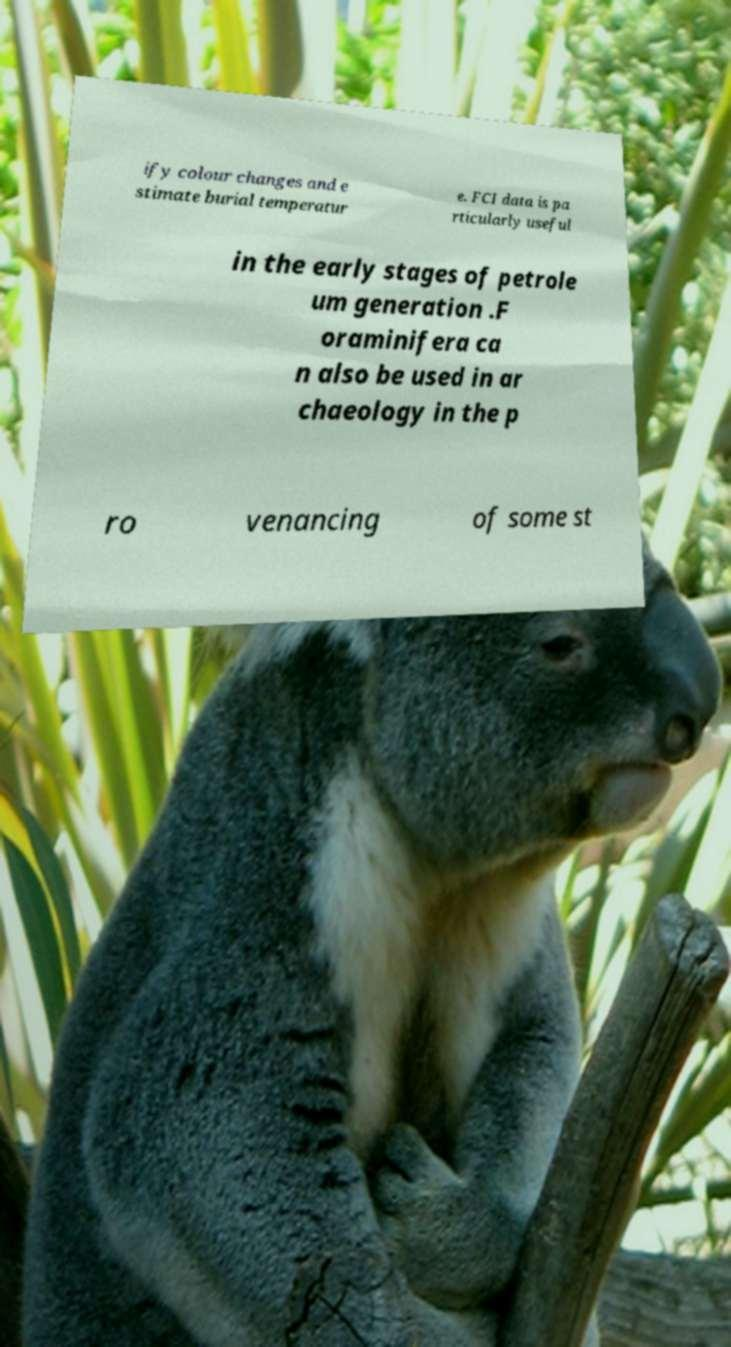What messages or text are displayed in this image? I need them in a readable, typed format. ify colour changes and e stimate burial temperatur e. FCI data is pa rticularly useful in the early stages of petrole um generation .F oraminifera ca n also be used in ar chaeology in the p ro venancing of some st 